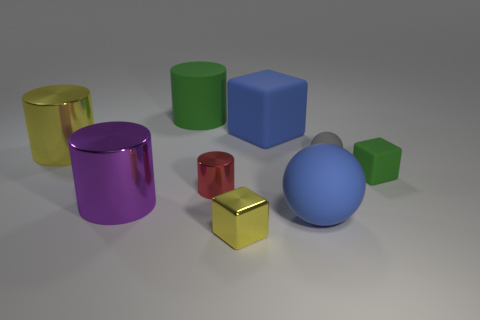Add 1 tiny rubber blocks. How many objects exist? 10 Subtract all blocks. How many objects are left? 6 Subtract 0 purple cubes. How many objects are left? 9 Subtract all large gray rubber spheres. Subtract all blue rubber objects. How many objects are left? 7 Add 8 red cylinders. How many red cylinders are left? 9 Add 3 cyan shiny things. How many cyan shiny things exist? 3 